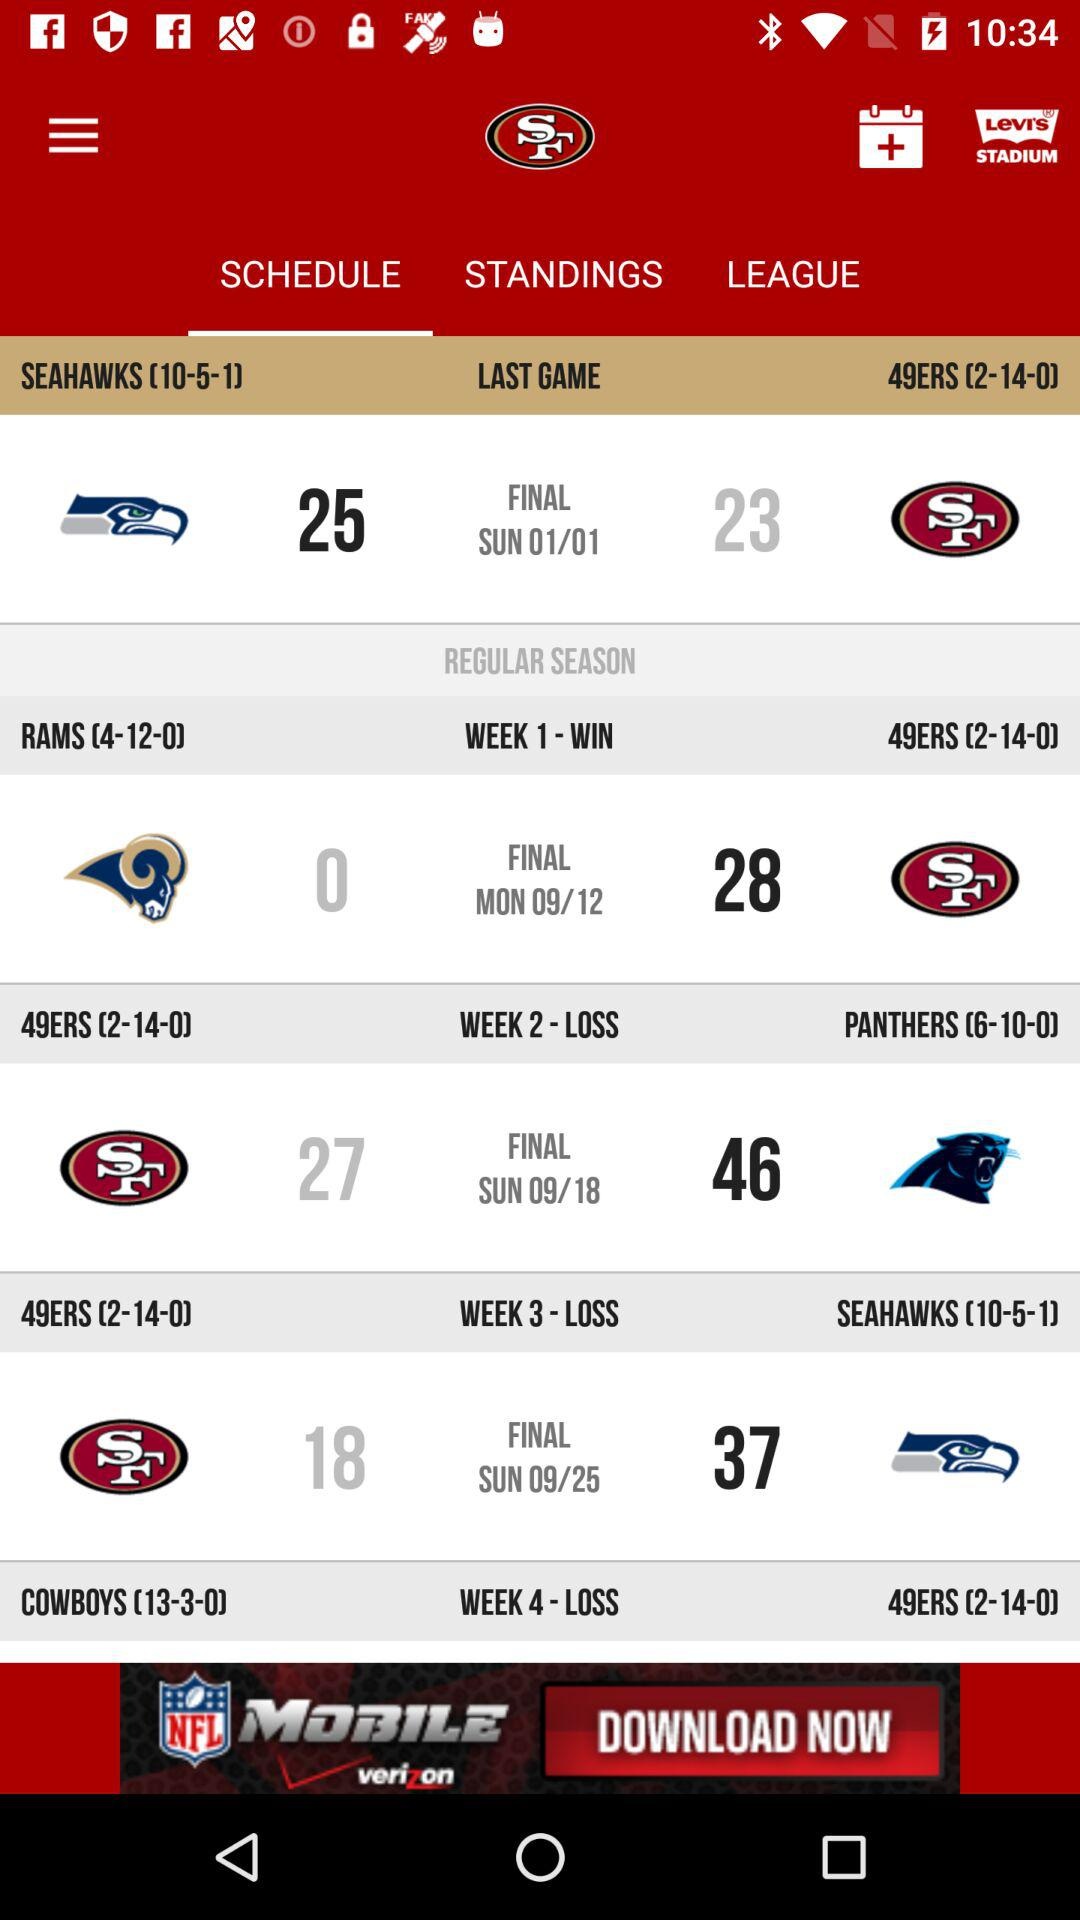What is the date of the last game? The date of the last game is Sunday, January 1. 